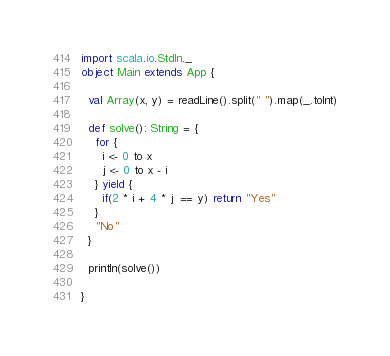Convert code to text. <code><loc_0><loc_0><loc_500><loc_500><_Scala_>import scala.io.StdIn._
object Main extends App {

  val Array(x, y) = readLine().split(" ").map(_.toInt)

  def solve(): String = {
    for {
      i <- 0 to x
      j <- 0 to x - i
    } yield {
      if(2 * i + 4 * j  == y) return "Yes"
    }
    "No"
  }

  println(solve())

}
</code> 